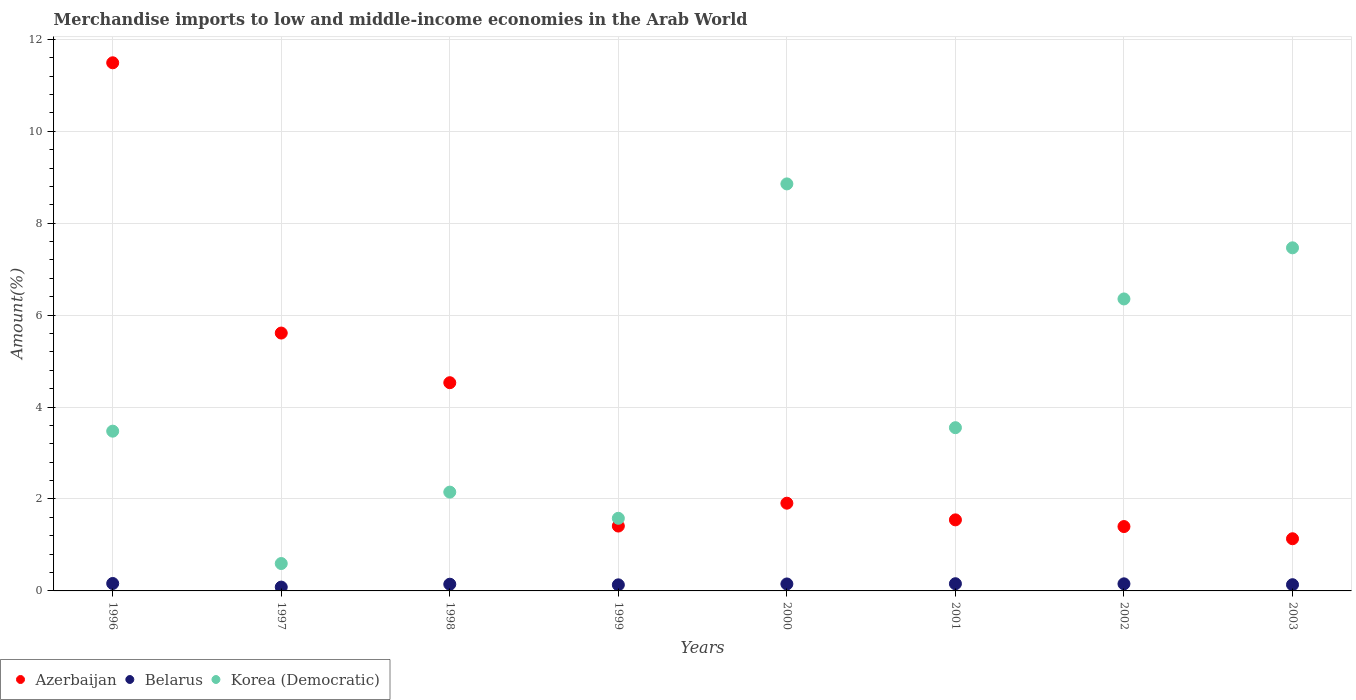How many different coloured dotlines are there?
Your response must be concise. 3. What is the percentage of amount earned from merchandise imports in Korea (Democratic) in 2000?
Provide a succinct answer. 8.86. Across all years, what is the maximum percentage of amount earned from merchandise imports in Korea (Democratic)?
Ensure brevity in your answer.  8.86. Across all years, what is the minimum percentage of amount earned from merchandise imports in Belarus?
Offer a terse response. 0.08. What is the total percentage of amount earned from merchandise imports in Azerbaijan in the graph?
Offer a terse response. 29.03. What is the difference between the percentage of amount earned from merchandise imports in Korea (Democratic) in 1999 and that in 2001?
Give a very brief answer. -1.97. What is the difference between the percentage of amount earned from merchandise imports in Belarus in 1997 and the percentage of amount earned from merchandise imports in Korea (Democratic) in 1999?
Make the answer very short. -1.5. What is the average percentage of amount earned from merchandise imports in Belarus per year?
Keep it short and to the point. 0.14. In the year 2001, what is the difference between the percentage of amount earned from merchandise imports in Korea (Democratic) and percentage of amount earned from merchandise imports in Azerbaijan?
Your response must be concise. 2.01. In how many years, is the percentage of amount earned from merchandise imports in Azerbaijan greater than 11.6 %?
Offer a terse response. 0. What is the ratio of the percentage of amount earned from merchandise imports in Belarus in 1996 to that in 1998?
Keep it short and to the point. 1.11. What is the difference between the highest and the second highest percentage of amount earned from merchandise imports in Belarus?
Your answer should be very brief. 0.01. What is the difference between the highest and the lowest percentage of amount earned from merchandise imports in Azerbaijan?
Make the answer very short. 10.36. In how many years, is the percentage of amount earned from merchandise imports in Korea (Democratic) greater than the average percentage of amount earned from merchandise imports in Korea (Democratic) taken over all years?
Your response must be concise. 3. Is the sum of the percentage of amount earned from merchandise imports in Korea (Democratic) in 1996 and 2000 greater than the maximum percentage of amount earned from merchandise imports in Azerbaijan across all years?
Offer a very short reply. Yes. Does the percentage of amount earned from merchandise imports in Belarus monotonically increase over the years?
Provide a succinct answer. No. How many years are there in the graph?
Ensure brevity in your answer.  8. Does the graph contain any zero values?
Offer a terse response. No. Does the graph contain grids?
Offer a very short reply. Yes. Where does the legend appear in the graph?
Offer a very short reply. Bottom left. How many legend labels are there?
Give a very brief answer. 3. What is the title of the graph?
Offer a very short reply. Merchandise imports to low and middle-income economies in the Arab World. What is the label or title of the X-axis?
Your response must be concise. Years. What is the label or title of the Y-axis?
Offer a terse response. Amount(%). What is the Amount(%) of Azerbaijan in 1996?
Ensure brevity in your answer.  11.49. What is the Amount(%) in Belarus in 1996?
Your answer should be very brief. 0.16. What is the Amount(%) of Korea (Democratic) in 1996?
Provide a short and direct response. 3.48. What is the Amount(%) of Azerbaijan in 1997?
Your answer should be very brief. 5.61. What is the Amount(%) in Belarus in 1997?
Your response must be concise. 0.08. What is the Amount(%) of Korea (Democratic) in 1997?
Give a very brief answer. 0.6. What is the Amount(%) of Azerbaijan in 1998?
Ensure brevity in your answer.  4.53. What is the Amount(%) of Belarus in 1998?
Make the answer very short. 0.15. What is the Amount(%) of Korea (Democratic) in 1998?
Keep it short and to the point. 2.15. What is the Amount(%) in Azerbaijan in 1999?
Make the answer very short. 1.41. What is the Amount(%) of Belarus in 1999?
Offer a very short reply. 0.13. What is the Amount(%) in Korea (Democratic) in 1999?
Offer a terse response. 1.58. What is the Amount(%) in Azerbaijan in 2000?
Your answer should be compact. 1.91. What is the Amount(%) in Belarus in 2000?
Your answer should be very brief. 0.15. What is the Amount(%) in Korea (Democratic) in 2000?
Provide a succinct answer. 8.86. What is the Amount(%) in Azerbaijan in 2001?
Offer a very short reply. 1.55. What is the Amount(%) in Belarus in 2001?
Provide a succinct answer. 0.16. What is the Amount(%) in Korea (Democratic) in 2001?
Your answer should be compact. 3.55. What is the Amount(%) in Azerbaijan in 2002?
Provide a short and direct response. 1.4. What is the Amount(%) of Belarus in 2002?
Your response must be concise. 0.15. What is the Amount(%) of Korea (Democratic) in 2002?
Keep it short and to the point. 6.35. What is the Amount(%) of Azerbaijan in 2003?
Ensure brevity in your answer.  1.14. What is the Amount(%) of Belarus in 2003?
Your answer should be compact. 0.14. What is the Amount(%) of Korea (Democratic) in 2003?
Offer a very short reply. 7.46. Across all years, what is the maximum Amount(%) in Azerbaijan?
Give a very brief answer. 11.49. Across all years, what is the maximum Amount(%) in Belarus?
Ensure brevity in your answer.  0.16. Across all years, what is the maximum Amount(%) in Korea (Democratic)?
Make the answer very short. 8.86. Across all years, what is the minimum Amount(%) in Azerbaijan?
Ensure brevity in your answer.  1.14. Across all years, what is the minimum Amount(%) in Belarus?
Offer a very short reply. 0.08. Across all years, what is the minimum Amount(%) of Korea (Democratic)?
Keep it short and to the point. 0.6. What is the total Amount(%) of Azerbaijan in the graph?
Offer a very short reply. 29.03. What is the total Amount(%) of Belarus in the graph?
Give a very brief answer. 1.12. What is the total Amount(%) of Korea (Democratic) in the graph?
Offer a very short reply. 34.03. What is the difference between the Amount(%) of Azerbaijan in 1996 and that in 1997?
Ensure brevity in your answer.  5.88. What is the difference between the Amount(%) in Belarus in 1996 and that in 1997?
Ensure brevity in your answer.  0.08. What is the difference between the Amount(%) in Korea (Democratic) in 1996 and that in 1997?
Provide a short and direct response. 2.88. What is the difference between the Amount(%) of Azerbaijan in 1996 and that in 1998?
Your answer should be compact. 6.96. What is the difference between the Amount(%) in Belarus in 1996 and that in 1998?
Provide a succinct answer. 0.02. What is the difference between the Amount(%) of Korea (Democratic) in 1996 and that in 1998?
Offer a very short reply. 1.33. What is the difference between the Amount(%) of Azerbaijan in 1996 and that in 1999?
Give a very brief answer. 10.08. What is the difference between the Amount(%) of Belarus in 1996 and that in 1999?
Your answer should be very brief. 0.03. What is the difference between the Amount(%) in Korea (Democratic) in 1996 and that in 1999?
Provide a short and direct response. 1.9. What is the difference between the Amount(%) in Azerbaijan in 1996 and that in 2000?
Keep it short and to the point. 9.58. What is the difference between the Amount(%) of Belarus in 1996 and that in 2000?
Offer a very short reply. 0.01. What is the difference between the Amount(%) in Korea (Democratic) in 1996 and that in 2000?
Keep it short and to the point. -5.38. What is the difference between the Amount(%) of Azerbaijan in 1996 and that in 2001?
Provide a succinct answer. 9.94. What is the difference between the Amount(%) of Belarus in 1996 and that in 2001?
Offer a very short reply. 0.01. What is the difference between the Amount(%) of Korea (Democratic) in 1996 and that in 2001?
Provide a short and direct response. -0.08. What is the difference between the Amount(%) in Azerbaijan in 1996 and that in 2002?
Keep it short and to the point. 10.09. What is the difference between the Amount(%) in Belarus in 1996 and that in 2002?
Keep it short and to the point. 0.01. What is the difference between the Amount(%) of Korea (Democratic) in 1996 and that in 2002?
Keep it short and to the point. -2.88. What is the difference between the Amount(%) in Azerbaijan in 1996 and that in 2003?
Keep it short and to the point. 10.36. What is the difference between the Amount(%) in Belarus in 1996 and that in 2003?
Give a very brief answer. 0.03. What is the difference between the Amount(%) of Korea (Democratic) in 1996 and that in 2003?
Your response must be concise. -3.99. What is the difference between the Amount(%) of Azerbaijan in 1997 and that in 1998?
Offer a very short reply. 1.08. What is the difference between the Amount(%) of Belarus in 1997 and that in 1998?
Offer a terse response. -0.06. What is the difference between the Amount(%) in Korea (Democratic) in 1997 and that in 1998?
Your response must be concise. -1.55. What is the difference between the Amount(%) in Azerbaijan in 1997 and that in 1999?
Provide a short and direct response. 4.2. What is the difference between the Amount(%) of Belarus in 1997 and that in 1999?
Ensure brevity in your answer.  -0.05. What is the difference between the Amount(%) in Korea (Democratic) in 1997 and that in 1999?
Ensure brevity in your answer.  -0.98. What is the difference between the Amount(%) in Azerbaijan in 1997 and that in 2000?
Your response must be concise. 3.7. What is the difference between the Amount(%) of Belarus in 1997 and that in 2000?
Provide a short and direct response. -0.07. What is the difference between the Amount(%) in Korea (Democratic) in 1997 and that in 2000?
Give a very brief answer. -8.26. What is the difference between the Amount(%) of Azerbaijan in 1997 and that in 2001?
Your answer should be compact. 4.06. What is the difference between the Amount(%) in Belarus in 1997 and that in 2001?
Provide a short and direct response. -0.07. What is the difference between the Amount(%) in Korea (Democratic) in 1997 and that in 2001?
Keep it short and to the point. -2.96. What is the difference between the Amount(%) in Azerbaijan in 1997 and that in 2002?
Offer a very short reply. 4.21. What is the difference between the Amount(%) of Belarus in 1997 and that in 2002?
Ensure brevity in your answer.  -0.07. What is the difference between the Amount(%) in Korea (Democratic) in 1997 and that in 2002?
Provide a short and direct response. -5.76. What is the difference between the Amount(%) in Azerbaijan in 1997 and that in 2003?
Keep it short and to the point. 4.48. What is the difference between the Amount(%) of Belarus in 1997 and that in 2003?
Make the answer very short. -0.05. What is the difference between the Amount(%) in Korea (Democratic) in 1997 and that in 2003?
Your answer should be compact. -6.87. What is the difference between the Amount(%) in Azerbaijan in 1998 and that in 1999?
Ensure brevity in your answer.  3.12. What is the difference between the Amount(%) of Belarus in 1998 and that in 1999?
Your answer should be compact. 0.01. What is the difference between the Amount(%) in Korea (Democratic) in 1998 and that in 1999?
Offer a very short reply. 0.57. What is the difference between the Amount(%) in Azerbaijan in 1998 and that in 2000?
Provide a succinct answer. 2.62. What is the difference between the Amount(%) of Belarus in 1998 and that in 2000?
Offer a very short reply. -0.01. What is the difference between the Amount(%) in Korea (Democratic) in 1998 and that in 2000?
Ensure brevity in your answer.  -6.71. What is the difference between the Amount(%) of Azerbaijan in 1998 and that in 2001?
Make the answer very short. 2.98. What is the difference between the Amount(%) in Belarus in 1998 and that in 2001?
Make the answer very short. -0.01. What is the difference between the Amount(%) in Korea (Democratic) in 1998 and that in 2001?
Give a very brief answer. -1.4. What is the difference between the Amount(%) of Azerbaijan in 1998 and that in 2002?
Keep it short and to the point. 3.13. What is the difference between the Amount(%) of Belarus in 1998 and that in 2002?
Ensure brevity in your answer.  -0.01. What is the difference between the Amount(%) in Korea (Democratic) in 1998 and that in 2002?
Your answer should be compact. -4.2. What is the difference between the Amount(%) of Azerbaijan in 1998 and that in 2003?
Offer a terse response. 3.4. What is the difference between the Amount(%) in Belarus in 1998 and that in 2003?
Give a very brief answer. 0.01. What is the difference between the Amount(%) of Korea (Democratic) in 1998 and that in 2003?
Ensure brevity in your answer.  -5.32. What is the difference between the Amount(%) of Azerbaijan in 1999 and that in 2000?
Make the answer very short. -0.5. What is the difference between the Amount(%) of Belarus in 1999 and that in 2000?
Your answer should be very brief. -0.02. What is the difference between the Amount(%) in Korea (Democratic) in 1999 and that in 2000?
Offer a very short reply. -7.28. What is the difference between the Amount(%) of Azerbaijan in 1999 and that in 2001?
Give a very brief answer. -0.13. What is the difference between the Amount(%) in Belarus in 1999 and that in 2001?
Your response must be concise. -0.02. What is the difference between the Amount(%) in Korea (Democratic) in 1999 and that in 2001?
Your response must be concise. -1.97. What is the difference between the Amount(%) of Azerbaijan in 1999 and that in 2002?
Your answer should be very brief. 0.01. What is the difference between the Amount(%) of Belarus in 1999 and that in 2002?
Make the answer very short. -0.02. What is the difference between the Amount(%) of Korea (Democratic) in 1999 and that in 2002?
Offer a very short reply. -4.77. What is the difference between the Amount(%) of Azerbaijan in 1999 and that in 2003?
Offer a terse response. 0.28. What is the difference between the Amount(%) in Belarus in 1999 and that in 2003?
Offer a terse response. -0. What is the difference between the Amount(%) in Korea (Democratic) in 1999 and that in 2003?
Make the answer very short. -5.88. What is the difference between the Amount(%) of Azerbaijan in 2000 and that in 2001?
Provide a succinct answer. 0.36. What is the difference between the Amount(%) of Belarus in 2000 and that in 2001?
Your response must be concise. -0.01. What is the difference between the Amount(%) of Korea (Democratic) in 2000 and that in 2001?
Your answer should be very brief. 5.3. What is the difference between the Amount(%) of Azerbaijan in 2000 and that in 2002?
Offer a very short reply. 0.51. What is the difference between the Amount(%) in Belarus in 2000 and that in 2002?
Your answer should be very brief. -0. What is the difference between the Amount(%) in Korea (Democratic) in 2000 and that in 2002?
Offer a terse response. 2.5. What is the difference between the Amount(%) in Azerbaijan in 2000 and that in 2003?
Keep it short and to the point. 0.77. What is the difference between the Amount(%) of Belarus in 2000 and that in 2003?
Your response must be concise. 0.02. What is the difference between the Amount(%) in Korea (Democratic) in 2000 and that in 2003?
Make the answer very short. 1.39. What is the difference between the Amount(%) in Azerbaijan in 2001 and that in 2002?
Provide a succinct answer. 0.15. What is the difference between the Amount(%) of Belarus in 2001 and that in 2002?
Ensure brevity in your answer.  0. What is the difference between the Amount(%) in Korea (Democratic) in 2001 and that in 2002?
Your response must be concise. -2.8. What is the difference between the Amount(%) in Azerbaijan in 2001 and that in 2003?
Offer a terse response. 0.41. What is the difference between the Amount(%) in Belarus in 2001 and that in 2003?
Ensure brevity in your answer.  0.02. What is the difference between the Amount(%) in Korea (Democratic) in 2001 and that in 2003?
Your response must be concise. -3.91. What is the difference between the Amount(%) of Azerbaijan in 2002 and that in 2003?
Your answer should be compact. 0.27. What is the difference between the Amount(%) of Belarus in 2002 and that in 2003?
Your response must be concise. 0.02. What is the difference between the Amount(%) in Korea (Democratic) in 2002 and that in 2003?
Ensure brevity in your answer.  -1.11. What is the difference between the Amount(%) in Azerbaijan in 1996 and the Amount(%) in Belarus in 1997?
Your answer should be compact. 11.41. What is the difference between the Amount(%) of Azerbaijan in 1996 and the Amount(%) of Korea (Democratic) in 1997?
Provide a short and direct response. 10.89. What is the difference between the Amount(%) of Belarus in 1996 and the Amount(%) of Korea (Democratic) in 1997?
Offer a terse response. -0.43. What is the difference between the Amount(%) of Azerbaijan in 1996 and the Amount(%) of Belarus in 1998?
Keep it short and to the point. 11.34. What is the difference between the Amount(%) of Azerbaijan in 1996 and the Amount(%) of Korea (Democratic) in 1998?
Your answer should be very brief. 9.34. What is the difference between the Amount(%) in Belarus in 1996 and the Amount(%) in Korea (Democratic) in 1998?
Offer a terse response. -1.99. What is the difference between the Amount(%) of Azerbaijan in 1996 and the Amount(%) of Belarus in 1999?
Ensure brevity in your answer.  11.36. What is the difference between the Amount(%) in Azerbaijan in 1996 and the Amount(%) in Korea (Democratic) in 1999?
Keep it short and to the point. 9.91. What is the difference between the Amount(%) of Belarus in 1996 and the Amount(%) of Korea (Democratic) in 1999?
Offer a very short reply. -1.42. What is the difference between the Amount(%) in Azerbaijan in 1996 and the Amount(%) in Belarus in 2000?
Keep it short and to the point. 11.34. What is the difference between the Amount(%) in Azerbaijan in 1996 and the Amount(%) in Korea (Democratic) in 2000?
Offer a very short reply. 2.64. What is the difference between the Amount(%) in Belarus in 1996 and the Amount(%) in Korea (Democratic) in 2000?
Offer a very short reply. -8.69. What is the difference between the Amount(%) of Azerbaijan in 1996 and the Amount(%) of Belarus in 2001?
Provide a succinct answer. 11.33. What is the difference between the Amount(%) in Azerbaijan in 1996 and the Amount(%) in Korea (Democratic) in 2001?
Keep it short and to the point. 7.94. What is the difference between the Amount(%) of Belarus in 1996 and the Amount(%) of Korea (Democratic) in 2001?
Keep it short and to the point. -3.39. What is the difference between the Amount(%) of Azerbaijan in 1996 and the Amount(%) of Belarus in 2002?
Provide a short and direct response. 11.34. What is the difference between the Amount(%) of Azerbaijan in 1996 and the Amount(%) of Korea (Democratic) in 2002?
Offer a very short reply. 5.14. What is the difference between the Amount(%) of Belarus in 1996 and the Amount(%) of Korea (Democratic) in 2002?
Offer a terse response. -6.19. What is the difference between the Amount(%) in Azerbaijan in 1996 and the Amount(%) in Belarus in 2003?
Give a very brief answer. 11.36. What is the difference between the Amount(%) in Azerbaijan in 1996 and the Amount(%) in Korea (Democratic) in 2003?
Give a very brief answer. 4.03. What is the difference between the Amount(%) of Belarus in 1996 and the Amount(%) of Korea (Democratic) in 2003?
Provide a succinct answer. -7.3. What is the difference between the Amount(%) of Azerbaijan in 1997 and the Amount(%) of Belarus in 1998?
Your answer should be very brief. 5.46. What is the difference between the Amount(%) in Azerbaijan in 1997 and the Amount(%) in Korea (Democratic) in 1998?
Keep it short and to the point. 3.46. What is the difference between the Amount(%) of Belarus in 1997 and the Amount(%) of Korea (Democratic) in 1998?
Make the answer very short. -2.07. What is the difference between the Amount(%) of Azerbaijan in 1997 and the Amount(%) of Belarus in 1999?
Give a very brief answer. 5.48. What is the difference between the Amount(%) in Azerbaijan in 1997 and the Amount(%) in Korea (Democratic) in 1999?
Offer a terse response. 4.03. What is the difference between the Amount(%) of Belarus in 1997 and the Amount(%) of Korea (Democratic) in 1999?
Offer a very short reply. -1.5. What is the difference between the Amount(%) of Azerbaijan in 1997 and the Amount(%) of Belarus in 2000?
Make the answer very short. 5.46. What is the difference between the Amount(%) of Azerbaijan in 1997 and the Amount(%) of Korea (Democratic) in 2000?
Provide a short and direct response. -3.25. What is the difference between the Amount(%) in Belarus in 1997 and the Amount(%) in Korea (Democratic) in 2000?
Offer a very short reply. -8.77. What is the difference between the Amount(%) in Azerbaijan in 1997 and the Amount(%) in Belarus in 2001?
Ensure brevity in your answer.  5.45. What is the difference between the Amount(%) in Azerbaijan in 1997 and the Amount(%) in Korea (Democratic) in 2001?
Give a very brief answer. 2.06. What is the difference between the Amount(%) of Belarus in 1997 and the Amount(%) of Korea (Democratic) in 2001?
Keep it short and to the point. -3.47. What is the difference between the Amount(%) of Azerbaijan in 1997 and the Amount(%) of Belarus in 2002?
Offer a terse response. 5.46. What is the difference between the Amount(%) of Azerbaijan in 1997 and the Amount(%) of Korea (Democratic) in 2002?
Provide a short and direct response. -0.74. What is the difference between the Amount(%) of Belarus in 1997 and the Amount(%) of Korea (Democratic) in 2002?
Your response must be concise. -6.27. What is the difference between the Amount(%) of Azerbaijan in 1997 and the Amount(%) of Belarus in 2003?
Provide a succinct answer. 5.47. What is the difference between the Amount(%) of Azerbaijan in 1997 and the Amount(%) of Korea (Democratic) in 2003?
Make the answer very short. -1.85. What is the difference between the Amount(%) of Belarus in 1997 and the Amount(%) of Korea (Democratic) in 2003?
Ensure brevity in your answer.  -7.38. What is the difference between the Amount(%) in Azerbaijan in 1998 and the Amount(%) in Belarus in 1999?
Give a very brief answer. 4.4. What is the difference between the Amount(%) of Azerbaijan in 1998 and the Amount(%) of Korea (Democratic) in 1999?
Your answer should be very brief. 2.95. What is the difference between the Amount(%) of Belarus in 1998 and the Amount(%) of Korea (Democratic) in 1999?
Your answer should be very brief. -1.43. What is the difference between the Amount(%) in Azerbaijan in 1998 and the Amount(%) in Belarus in 2000?
Offer a very short reply. 4.38. What is the difference between the Amount(%) in Azerbaijan in 1998 and the Amount(%) in Korea (Democratic) in 2000?
Offer a terse response. -4.33. What is the difference between the Amount(%) of Belarus in 1998 and the Amount(%) of Korea (Democratic) in 2000?
Provide a short and direct response. -8.71. What is the difference between the Amount(%) in Azerbaijan in 1998 and the Amount(%) in Belarus in 2001?
Ensure brevity in your answer.  4.37. What is the difference between the Amount(%) in Azerbaijan in 1998 and the Amount(%) in Korea (Democratic) in 2001?
Your answer should be very brief. 0.98. What is the difference between the Amount(%) of Belarus in 1998 and the Amount(%) of Korea (Democratic) in 2001?
Ensure brevity in your answer.  -3.41. What is the difference between the Amount(%) of Azerbaijan in 1998 and the Amount(%) of Belarus in 2002?
Your response must be concise. 4.38. What is the difference between the Amount(%) in Azerbaijan in 1998 and the Amount(%) in Korea (Democratic) in 2002?
Your response must be concise. -1.82. What is the difference between the Amount(%) of Belarus in 1998 and the Amount(%) of Korea (Democratic) in 2002?
Your answer should be compact. -6.21. What is the difference between the Amount(%) in Azerbaijan in 1998 and the Amount(%) in Belarus in 2003?
Your answer should be compact. 4.39. What is the difference between the Amount(%) in Azerbaijan in 1998 and the Amount(%) in Korea (Democratic) in 2003?
Your answer should be very brief. -2.93. What is the difference between the Amount(%) of Belarus in 1998 and the Amount(%) of Korea (Democratic) in 2003?
Give a very brief answer. -7.32. What is the difference between the Amount(%) in Azerbaijan in 1999 and the Amount(%) in Belarus in 2000?
Ensure brevity in your answer.  1.26. What is the difference between the Amount(%) in Azerbaijan in 1999 and the Amount(%) in Korea (Democratic) in 2000?
Offer a terse response. -7.44. What is the difference between the Amount(%) of Belarus in 1999 and the Amount(%) of Korea (Democratic) in 2000?
Provide a succinct answer. -8.72. What is the difference between the Amount(%) of Azerbaijan in 1999 and the Amount(%) of Belarus in 2001?
Provide a short and direct response. 1.25. What is the difference between the Amount(%) of Azerbaijan in 1999 and the Amount(%) of Korea (Democratic) in 2001?
Offer a terse response. -2.14. What is the difference between the Amount(%) in Belarus in 1999 and the Amount(%) in Korea (Democratic) in 2001?
Your response must be concise. -3.42. What is the difference between the Amount(%) of Azerbaijan in 1999 and the Amount(%) of Belarus in 2002?
Keep it short and to the point. 1.26. What is the difference between the Amount(%) of Azerbaijan in 1999 and the Amount(%) of Korea (Democratic) in 2002?
Your answer should be compact. -4.94. What is the difference between the Amount(%) of Belarus in 1999 and the Amount(%) of Korea (Democratic) in 2002?
Make the answer very short. -6.22. What is the difference between the Amount(%) in Azerbaijan in 1999 and the Amount(%) in Belarus in 2003?
Provide a short and direct response. 1.28. What is the difference between the Amount(%) of Azerbaijan in 1999 and the Amount(%) of Korea (Democratic) in 2003?
Your response must be concise. -6.05. What is the difference between the Amount(%) in Belarus in 1999 and the Amount(%) in Korea (Democratic) in 2003?
Ensure brevity in your answer.  -7.33. What is the difference between the Amount(%) in Azerbaijan in 2000 and the Amount(%) in Belarus in 2001?
Give a very brief answer. 1.75. What is the difference between the Amount(%) in Azerbaijan in 2000 and the Amount(%) in Korea (Democratic) in 2001?
Make the answer very short. -1.64. What is the difference between the Amount(%) of Belarus in 2000 and the Amount(%) of Korea (Democratic) in 2001?
Give a very brief answer. -3.4. What is the difference between the Amount(%) of Azerbaijan in 2000 and the Amount(%) of Belarus in 2002?
Offer a very short reply. 1.75. What is the difference between the Amount(%) in Azerbaijan in 2000 and the Amount(%) in Korea (Democratic) in 2002?
Keep it short and to the point. -4.44. What is the difference between the Amount(%) of Belarus in 2000 and the Amount(%) of Korea (Democratic) in 2002?
Offer a terse response. -6.2. What is the difference between the Amount(%) in Azerbaijan in 2000 and the Amount(%) in Belarus in 2003?
Offer a terse response. 1.77. What is the difference between the Amount(%) in Azerbaijan in 2000 and the Amount(%) in Korea (Democratic) in 2003?
Your answer should be very brief. -5.56. What is the difference between the Amount(%) in Belarus in 2000 and the Amount(%) in Korea (Democratic) in 2003?
Keep it short and to the point. -7.31. What is the difference between the Amount(%) of Azerbaijan in 2001 and the Amount(%) of Belarus in 2002?
Offer a very short reply. 1.39. What is the difference between the Amount(%) of Azerbaijan in 2001 and the Amount(%) of Korea (Democratic) in 2002?
Make the answer very short. -4.81. What is the difference between the Amount(%) of Belarus in 2001 and the Amount(%) of Korea (Democratic) in 2002?
Ensure brevity in your answer.  -6.2. What is the difference between the Amount(%) of Azerbaijan in 2001 and the Amount(%) of Belarus in 2003?
Your answer should be compact. 1.41. What is the difference between the Amount(%) in Azerbaijan in 2001 and the Amount(%) in Korea (Democratic) in 2003?
Your answer should be compact. -5.92. What is the difference between the Amount(%) in Belarus in 2001 and the Amount(%) in Korea (Democratic) in 2003?
Give a very brief answer. -7.31. What is the difference between the Amount(%) in Azerbaijan in 2002 and the Amount(%) in Belarus in 2003?
Ensure brevity in your answer.  1.27. What is the difference between the Amount(%) of Azerbaijan in 2002 and the Amount(%) of Korea (Democratic) in 2003?
Offer a very short reply. -6.06. What is the difference between the Amount(%) in Belarus in 2002 and the Amount(%) in Korea (Democratic) in 2003?
Ensure brevity in your answer.  -7.31. What is the average Amount(%) of Azerbaijan per year?
Make the answer very short. 3.63. What is the average Amount(%) of Belarus per year?
Your response must be concise. 0.14. What is the average Amount(%) of Korea (Democratic) per year?
Keep it short and to the point. 4.25. In the year 1996, what is the difference between the Amount(%) of Azerbaijan and Amount(%) of Belarus?
Your answer should be compact. 11.33. In the year 1996, what is the difference between the Amount(%) of Azerbaijan and Amount(%) of Korea (Democratic)?
Provide a short and direct response. 8.01. In the year 1996, what is the difference between the Amount(%) in Belarus and Amount(%) in Korea (Democratic)?
Keep it short and to the point. -3.31. In the year 1997, what is the difference between the Amount(%) of Azerbaijan and Amount(%) of Belarus?
Keep it short and to the point. 5.53. In the year 1997, what is the difference between the Amount(%) in Azerbaijan and Amount(%) in Korea (Democratic)?
Provide a short and direct response. 5.01. In the year 1997, what is the difference between the Amount(%) in Belarus and Amount(%) in Korea (Democratic)?
Provide a short and direct response. -0.51. In the year 1998, what is the difference between the Amount(%) of Azerbaijan and Amount(%) of Belarus?
Provide a succinct answer. 4.38. In the year 1998, what is the difference between the Amount(%) of Azerbaijan and Amount(%) of Korea (Democratic)?
Your answer should be compact. 2.38. In the year 1998, what is the difference between the Amount(%) of Belarus and Amount(%) of Korea (Democratic)?
Your answer should be compact. -2. In the year 1999, what is the difference between the Amount(%) in Azerbaijan and Amount(%) in Belarus?
Offer a very short reply. 1.28. In the year 1999, what is the difference between the Amount(%) in Azerbaijan and Amount(%) in Korea (Democratic)?
Offer a very short reply. -0.17. In the year 1999, what is the difference between the Amount(%) of Belarus and Amount(%) of Korea (Democratic)?
Your answer should be compact. -1.45. In the year 2000, what is the difference between the Amount(%) of Azerbaijan and Amount(%) of Belarus?
Keep it short and to the point. 1.76. In the year 2000, what is the difference between the Amount(%) of Azerbaijan and Amount(%) of Korea (Democratic)?
Provide a short and direct response. -6.95. In the year 2000, what is the difference between the Amount(%) of Belarus and Amount(%) of Korea (Democratic)?
Give a very brief answer. -8.7. In the year 2001, what is the difference between the Amount(%) of Azerbaijan and Amount(%) of Belarus?
Provide a short and direct response. 1.39. In the year 2001, what is the difference between the Amount(%) of Azerbaijan and Amount(%) of Korea (Democratic)?
Make the answer very short. -2.01. In the year 2001, what is the difference between the Amount(%) of Belarus and Amount(%) of Korea (Democratic)?
Ensure brevity in your answer.  -3.39. In the year 2002, what is the difference between the Amount(%) of Azerbaijan and Amount(%) of Belarus?
Ensure brevity in your answer.  1.25. In the year 2002, what is the difference between the Amount(%) in Azerbaijan and Amount(%) in Korea (Democratic)?
Make the answer very short. -4.95. In the year 2002, what is the difference between the Amount(%) in Belarus and Amount(%) in Korea (Democratic)?
Offer a very short reply. -6.2. In the year 2003, what is the difference between the Amount(%) of Azerbaijan and Amount(%) of Korea (Democratic)?
Provide a short and direct response. -6.33. In the year 2003, what is the difference between the Amount(%) of Belarus and Amount(%) of Korea (Democratic)?
Provide a succinct answer. -7.33. What is the ratio of the Amount(%) in Azerbaijan in 1996 to that in 1997?
Make the answer very short. 2.05. What is the ratio of the Amount(%) in Belarus in 1996 to that in 1997?
Provide a short and direct response. 1.94. What is the ratio of the Amount(%) of Korea (Democratic) in 1996 to that in 1997?
Offer a terse response. 5.83. What is the ratio of the Amount(%) in Azerbaijan in 1996 to that in 1998?
Your response must be concise. 2.54. What is the ratio of the Amount(%) in Belarus in 1996 to that in 1998?
Ensure brevity in your answer.  1.11. What is the ratio of the Amount(%) in Korea (Democratic) in 1996 to that in 1998?
Keep it short and to the point. 1.62. What is the ratio of the Amount(%) of Azerbaijan in 1996 to that in 1999?
Your response must be concise. 8.14. What is the ratio of the Amount(%) in Belarus in 1996 to that in 1999?
Give a very brief answer. 1.22. What is the ratio of the Amount(%) of Korea (Democratic) in 1996 to that in 1999?
Make the answer very short. 2.2. What is the ratio of the Amount(%) in Azerbaijan in 1996 to that in 2000?
Keep it short and to the point. 6.02. What is the ratio of the Amount(%) of Belarus in 1996 to that in 2000?
Ensure brevity in your answer.  1.07. What is the ratio of the Amount(%) of Korea (Democratic) in 1996 to that in 2000?
Provide a succinct answer. 0.39. What is the ratio of the Amount(%) of Azerbaijan in 1996 to that in 2001?
Make the answer very short. 7.43. What is the ratio of the Amount(%) in Belarus in 1996 to that in 2001?
Your answer should be compact. 1.03. What is the ratio of the Amount(%) of Korea (Democratic) in 1996 to that in 2001?
Provide a succinct answer. 0.98. What is the ratio of the Amount(%) in Azerbaijan in 1996 to that in 2002?
Offer a very short reply. 8.2. What is the ratio of the Amount(%) of Belarus in 1996 to that in 2002?
Give a very brief answer. 1.05. What is the ratio of the Amount(%) in Korea (Democratic) in 1996 to that in 2002?
Offer a very short reply. 0.55. What is the ratio of the Amount(%) in Azerbaijan in 1996 to that in 2003?
Keep it short and to the point. 10.12. What is the ratio of the Amount(%) in Belarus in 1996 to that in 2003?
Offer a terse response. 1.19. What is the ratio of the Amount(%) in Korea (Democratic) in 1996 to that in 2003?
Provide a succinct answer. 0.47. What is the ratio of the Amount(%) in Azerbaijan in 1997 to that in 1998?
Offer a terse response. 1.24. What is the ratio of the Amount(%) of Belarus in 1997 to that in 1998?
Keep it short and to the point. 0.57. What is the ratio of the Amount(%) in Korea (Democratic) in 1997 to that in 1998?
Your answer should be compact. 0.28. What is the ratio of the Amount(%) of Azerbaijan in 1997 to that in 1999?
Make the answer very short. 3.98. What is the ratio of the Amount(%) in Belarus in 1997 to that in 1999?
Provide a short and direct response. 0.63. What is the ratio of the Amount(%) of Korea (Democratic) in 1997 to that in 1999?
Your answer should be compact. 0.38. What is the ratio of the Amount(%) of Azerbaijan in 1997 to that in 2000?
Make the answer very short. 2.94. What is the ratio of the Amount(%) of Belarus in 1997 to that in 2000?
Provide a short and direct response. 0.55. What is the ratio of the Amount(%) in Korea (Democratic) in 1997 to that in 2000?
Offer a terse response. 0.07. What is the ratio of the Amount(%) in Azerbaijan in 1997 to that in 2001?
Your answer should be very brief. 3.63. What is the ratio of the Amount(%) in Belarus in 1997 to that in 2001?
Offer a very short reply. 0.53. What is the ratio of the Amount(%) of Korea (Democratic) in 1997 to that in 2001?
Offer a terse response. 0.17. What is the ratio of the Amount(%) in Azerbaijan in 1997 to that in 2002?
Provide a succinct answer. 4.01. What is the ratio of the Amount(%) of Belarus in 1997 to that in 2002?
Keep it short and to the point. 0.54. What is the ratio of the Amount(%) in Korea (Democratic) in 1997 to that in 2002?
Make the answer very short. 0.09. What is the ratio of the Amount(%) in Azerbaijan in 1997 to that in 2003?
Your answer should be compact. 4.94. What is the ratio of the Amount(%) in Belarus in 1997 to that in 2003?
Make the answer very short. 0.62. What is the ratio of the Amount(%) of Korea (Democratic) in 1997 to that in 2003?
Provide a short and direct response. 0.08. What is the ratio of the Amount(%) in Azerbaijan in 1998 to that in 1999?
Offer a terse response. 3.21. What is the ratio of the Amount(%) in Belarus in 1998 to that in 1999?
Offer a very short reply. 1.1. What is the ratio of the Amount(%) in Korea (Democratic) in 1998 to that in 1999?
Your response must be concise. 1.36. What is the ratio of the Amount(%) in Azerbaijan in 1998 to that in 2000?
Make the answer very short. 2.37. What is the ratio of the Amount(%) in Belarus in 1998 to that in 2000?
Ensure brevity in your answer.  0.96. What is the ratio of the Amount(%) in Korea (Democratic) in 1998 to that in 2000?
Make the answer very short. 0.24. What is the ratio of the Amount(%) of Azerbaijan in 1998 to that in 2001?
Provide a succinct answer. 2.93. What is the ratio of the Amount(%) of Belarus in 1998 to that in 2001?
Your response must be concise. 0.93. What is the ratio of the Amount(%) in Korea (Democratic) in 1998 to that in 2001?
Your answer should be very brief. 0.61. What is the ratio of the Amount(%) of Azerbaijan in 1998 to that in 2002?
Offer a terse response. 3.23. What is the ratio of the Amount(%) of Belarus in 1998 to that in 2002?
Your answer should be compact. 0.95. What is the ratio of the Amount(%) of Korea (Democratic) in 1998 to that in 2002?
Offer a terse response. 0.34. What is the ratio of the Amount(%) in Azerbaijan in 1998 to that in 2003?
Provide a short and direct response. 3.99. What is the ratio of the Amount(%) in Belarus in 1998 to that in 2003?
Ensure brevity in your answer.  1.08. What is the ratio of the Amount(%) of Korea (Democratic) in 1998 to that in 2003?
Ensure brevity in your answer.  0.29. What is the ratio of the Amount(%) in Azerbaijan in 1999 to that in 2000?
Offer a very short reply. 0.74. What is the ratio of the Amount(%) in Belarus in 1999 to that in 2000?
Your response must be concise. 0.87. What is the ratio of the Amount(%) of Korea (Democratic) in 1999 to that in 2000?
Ensure brevity in your answer.  0.18. What is the ratio of the Amount(%) of Azerbaijan in 1999 to that in 2001?
Your answer should be compact. 0.91. What is the ratio of the Amount(%) of Belarus in 1999 to that in 2001?
Make the answer very short. 0.85. What is the ratio of the Amount(%) in Korea (Democratic) in 1999 to that in 2001?
Keep it short and to the point. 0.44. What is the ratio of the Amount(%) of Azerbaijan in 1999 to that in 2002?
Ensure brevity in your answer.  1.01. What is the ratio of the Amount(%) of Belarus in 1999 to that in 2002?
Provide a succinct answer. 0.86. What is the ratio of the Amount(%) of Korea (Democratic) in 1999 to that in 2002?
Offer a very short reply. 0.25. What is the ratio of the Amount(%) in Azerbaijan in 1999 to that in 2003?
Offer a terse response. 1.24. What is the ratio of the Amount(%) of Belarus in 1999 to that in 2003?
Your response must be concise. 0.98. What is the ratio of the Amount(%) of Korea (Democratic) in 1999 to that in 2003?
Your response must be concise. 0.21. What is the ratio of the Amount(%) of Azerbaijan in 2000 to that in 2001?
Offer a terse response. 1.23. What is the ratio of the Amount(%) of Belarus in 2000 to that in 2001?
Your response must be concise. 0.97. What is the ratio of the Amount(%) in Korea (Democratic) in 2000 to that in 2001?
Offer a very short reply. 2.49. What is the ratio of the Amount(%) in Azerbaijan in 2000 to that in 2002?
Ensure brevity in your answer.  1.36. What is the ratio of the Amount(%) of Belarus in 2000 to that in 2002?
Give a very brief answer. 0.98. What is the ratio of the Amount(%) in Korea (Democratic) in 2000 to that in 2002?
Your response must be concise. 1.39. What is the ratio of the Amount(%) in Azerbaijan in 2000 to that in 2003?
Provide a succinct answer. 1.68. What is the ratio of the Amount(%) of Belarus in 2000 to that in 2003?
Give a very brief answer. 1.12. What is the ratio of the Amount(%) in Korea (Democratic) in 2000 to that in 2003?
Make the answer very short. 1.19. What is the ratio of the Amount(%) of Azerbaijan in 2001 to that in 2002?
Offer a terse response. 1.1. What is the ratio of the Amount(%) of Belarus in 2001 to that in 2002?
Make the answer very short. 1.01. What is the ratio of the Amount(%) of Korea (Democratic) in 2001 to that in 2002?
Ensure brevity in your answer.  0.56. What is the ratio of the Amount(%) of Azerbaijan in 2001 to that in 2003?
Your response must be concise. 1.36. What is the ratio of the Amount(%) of Belarus in 2001 to that in 2003?
Your response must be concise. 1.16. What is the ratio of the Amount(%) of Korea (Democratic) in 2001 to that in 2003?
Offer a terse response. 0.48. What is the ratio of the Amount(%) of Azerbaijan in 2002 to that in 2003?
Make the answer very short. 1.23. What is the ratio of the Amount(%) in Belarus in 2002 to that in 2003?
Offer a very short reply. 1.14. What is the ratio of the Amount(%) of Korea (Democratic) in 2002 to that in 2003?
Offer a very short reply. 0.85. What is the difference between the highest and the second highest Amount(%) in Azerbaijan?
Give a very brief answer. 5.88. What is the difference between the highest and the second highest Amount(%) of Belarus?
Your answer should be compact. 0.01. What is the difference between the highest and the second highest Amount(%) of Korea (Democratic)?
Your response must be concise. 1.39. What is the difference between the highest and the lowest Amount(%) in Azerbaijan?
Offer a terse response. 10.36. What is the difference between the highest and the lowest Amount(%) in Belarus?
Your response must be concise. 0.08. What is the difference between the highest and the lowest Amount(%) of Korea (Democratic)?
Provide a succinct answer. 8.26. 